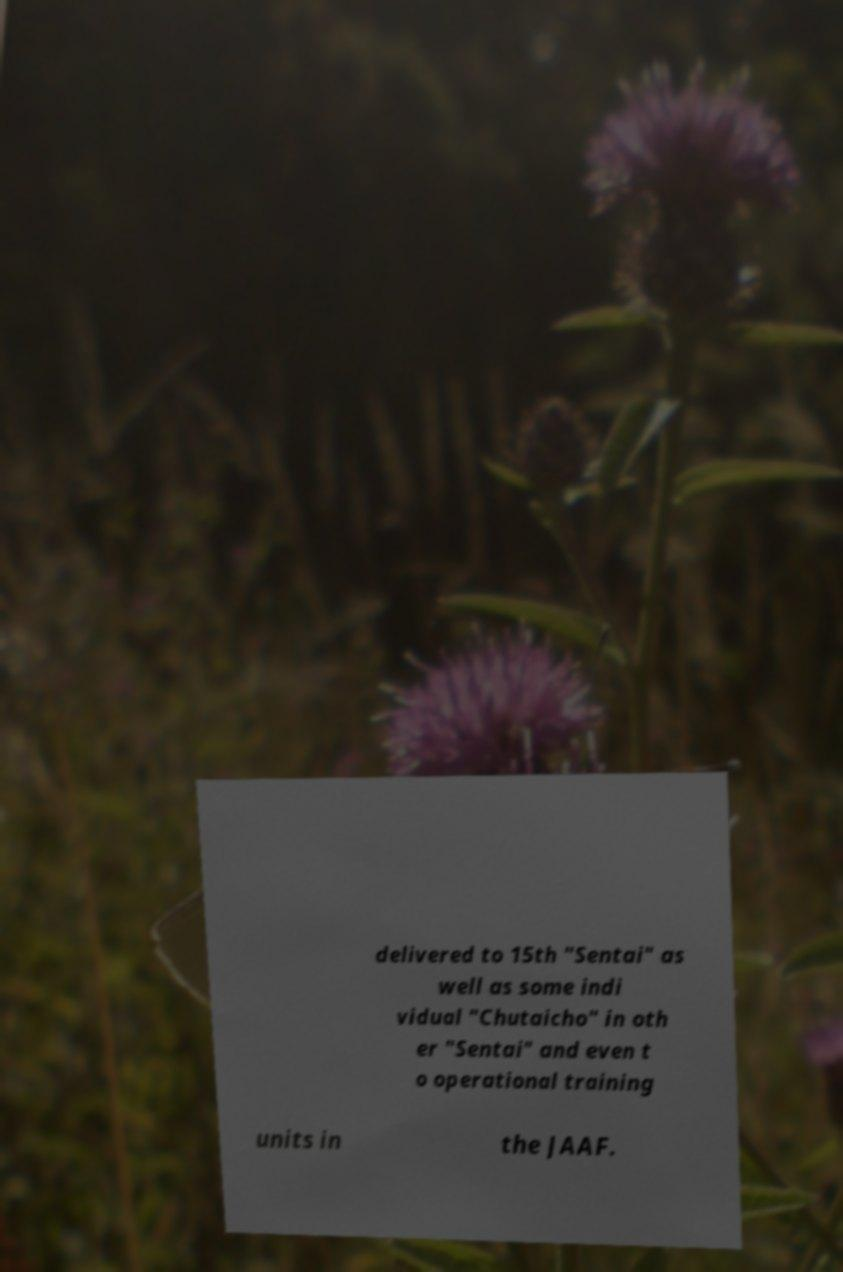Please read and relay the text visible in this image. What does it say? delivered to 15th "Sentai" as well as some indi vidual "Chutaicho" in oth er "Sentai" and even t o operational training units in the JAAF. 